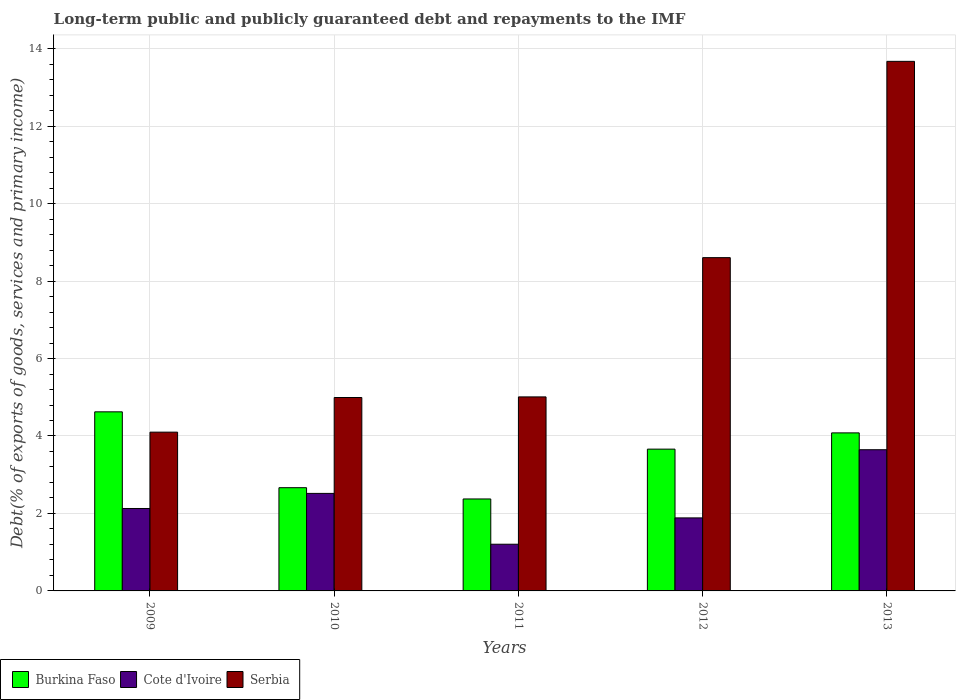How many groups of bars are there?
Ensure brevity in your answer.  5. Are the number of bars per tick equal to the number of legend labels?
Offer a terse response. Yes. Are the number of bars on each tick of the X-axis equal?
Provide a succinct answer. Yes. In how many cases, is the number of bars for a given year not equal to the number of legend labels?
Offer a very short reply. 0. What is the debt and repayments in Serbia in 2010?
Provide a succinct answer. 4.99. Across all years, what is the maximum debt and repayments in Serbia?
Your response must be concise. 13.67. Across all years, what is the minimum debt and repayments in Burkina Faso?
Your response must be concise. 2.37. In which year was the debt and repayments in Burkina Faso minimum?
Offer a terse response. 2011. What is the total debt and repayments in Cote d'Ivoire in the graph?
Your answer should be very brief. 11.38. What is the difference between the debt and repayments in Burkina Faso in 2009 and that in 2011?
Provide a short and direct response. 2.25. What is the difference between the debt and repayments in Burkina Faso in 2009 and the debt and repayments in Cote d'Ivoire in 2013?
Ensure brevity in your answer.  0.98. What is the average debt and repayments in Cote d'Ivoire per year?
Offer a terse response. 2.28. In the year 2010, what is the difference between the debt and repayments in Burkina Faso and debt and repayments in Serbia?
Offer a very short reply. -2.33. In how many years, is the debt and repayments in Serbia greater than 3.2 %?
Keep it short and to the point. 5. What is the ratio of the debt and repayments in Cote d'Ivoire in 2009 to that in 2011?
Your response must be concise. 1.77. Is the debt and repayments in Cote d'Ivoire in 2010 less than that in 2011?
Your answer should be very brief. No. Is the difference between the debt and repayments in Burkina Faso in 2009 and 2011 greater than the difference between the debt and repayments in Serbia in 2009 and 2011?
Offer a terse response. Yes. What is the difference between the highest and the second highest debt and repayments in Burkina Faso?
Offer a very short reply. 0.54. What is the difference between the highest and the lowest debt and repayments in Burkina Faso?
Your answer should be very brief. 2.25. What does the 2nd bar from the left in 2009 represents?
Keep it short and to the point. Cote d'Ivoire. What does the 1st bar from the right in 2009 represents?
Your answer should be compact. Serbia. Are all the bars in the graph horizontal?
Your response must be concise. No. How many years are there in the graph?
Offer a very short reply. 5. Does the graph contain grids?
Ensure brevity in your answer.  Yes. How many legend labels are there?
Offer a terse response. 3. How are the legend labels stacked?
Ensure brevity in your answer.  Horizontal. What is the title of the graph?
Provide a succinct answer. Long-term public and publicly guaranteed debt and repayments to the IMF. Does "Pakistan" appear as one of the legend labels in the graph?
Make the answer very short. No. What is the label or title of the X-axis?
Provide a short and direct response. Years. What is the label or title of the Y-axis?
Your answer should be compact. Debt(% of exports of goods, services and primary income). What is the Debt(% of exports of goods, services and primary income) of Burkina Faso in 2009?
Ensure brevity in your answer.  4.62. What is the Debt(% of exports of goods, services and primary income) in Cote d'Ivoire in 2009?
Provide a short and direct response. 2.13. What is the Debt(% of exports of goods, services and primary income) in Serbia in 2009?
Your response must be concise. 4.1. What is the Debt(% of exports of goods, services and primary income) of Burkina Faso in 2010?
Your answer should be compact. 2.67. What is the Debt(% of exports of goods, services and primary income) in Cote d'Ivoire in 2010?
Provide a short and direct response. 2.52. What is the Debt(% of exports of goods, services and primary income) of Serbia in 2010?
Give a very brief answer. 4.99. What is the Debt(% of exports of goods, services and primary income) in Burkina Faso in 2011?
Your answer should be very brief. 2.37. What is the Debt(% of exports of goods, services and primary income) of Cote d'Ivoire in 2011?
Provide a succinct answer. 1.21. What is the Debt(% of exports of goods, services and primary income) in Serbia in 2011?
Your answer should be very brief. 5.01. What is the Debt(% of exports of goods, services and primary income) in Burkina Faso in 2012?
Provide a succinct answer. 3.66. What is the Debt(% of exports of goods, services and primary income) in Cote d'Ivoire in 2012?
Your answer should be compact. 1.89. What is the Debt(% of exports of goods, services and primary income) in Serbia in 2012?
Your answer should be compact. 8.6. What is the Debt(% of exports of goods, services and primary income) in Burkina Faso in 2013?
Ensure brevity in your answer.  4.08. What is the Debt(% of exports of goods, services and primary income) in Cote d'Ivoire in 2013?
Give a very brief answer. 3.65. What is the Debt(% of exports of goods, services and primary income) of Serbia in 2013?
Give a very brief answer. 13.67. Across all years, what is the maximum Debt(% of exports of goods, services and primary income) of Burkina Faso?
Offer a very short reply. 4.62. Across all years, what is the maximum Debt(% of exports of goods, services and primary income) of Cote d'Ivoire?
Offer a very short reply. 3.65. Across all years, what is the maximum Debt(% of exports of goods, services and primary income) in Serbia?
Your answer should be very brief. 13.67. Across all years, what is the minimum Debt(% of exports of goods, services and primary income) in Burkina Faso?
Give a very brief answer. 2.37. Across all years, what is the minimum Debt(% of exports of goods, services and primary income) in Cote d'Ivoire?
Keep it short and to the point. 1.21. Across all years, what is the minimum Debt(% of exports of goods, services and primary income) in Serbia?
Provide a short and direct response. 4.1. What is the total Debt(% of exports of goods, services and primary income) in Burkina Faso in the graph?
Ensure brevity in your answer.  17.4. What is the total Debt(% of exports of goods, services and primary income) in Cote d'Ivoire in the graph?
Offer a terse response. 11.38. What is the total Debt(% of exports of goods, services and primary income) in Serbia in the graph?
Your answer should be very brief. 36.38. What is the difference between the Debt(% of exports of goods, services and primary income) of Burkina Faso in 2009 and that in 2010?
Offer a very short reply. 1.96. What is the difference between the Debt(% of exports of goods, services and primary income) in Cote d'Ivoire in 2009 and that in 2010?
Ensure brevity in your answer.  -0.39. What is the difference between the Debt(% of exports of goods, services and primary income) in Serbia in 2009 and that in 2010?
Give a very brief answer. -0.89. What is the difference between the Debt(% of exports of goods, services and primary income) of Burkina Faso in 2009 and that in 2011?
Provide a short and direct response. 2.25. What is the difference between the Debt(% of exports of goods, services and primary income) in Cote d'Ivoire in 2009 and that in 2011?
Your answer should be compact. 0.92. What is the difference between the Debt(% of exports of goods, services and primary income) of Serbia in 2009 and that in 2011?
Give a very brief answer. -0.91. What is the difference between the Debt(% of exports of goods, services and primary income) in Burkina Faso in 2009 and that in 2012?
Provide a short and direct response. 0.96. What is the difference between the Debt(% of exports of goods, services and primary income) of Cote d'Ivoire in 2009 and that in 2012?
Your response must be concise. 0.24. What is the difference between the Debt(% of exports of goods, services and primary income) of Serbia in 2009 and that in 2012?
Your response must be concise. -4.51. What is the difference between the Debt(% of exports of goods, services and primary income) in Burkina Faso in 2009 and that in 2013?
Your answer should be very brief. 0.54. What is the difference between the Debt(% of exports of goods, services and primary income) of Cote d'Ivoire in 2009 and that in 2013?
Offer a terse response. -1.52. What is the difference between the Debt(% of exports of goods, services and primary income) of Serbia in 2009 and that in 2013?
Offer a very short reply. -9.57. What is the difference between the Debt(% of exports of goods, services and primary income) of Burkina Faso in 2010 and that in 2011?
Offer a very short reply. 0.29. What is the difference between the Debt(% of exports of goods, services and primary income) in Cote d'Ivoire in 2010 and that in 2011?
Your answer should be compact. 1.31. What is the difference between the Debt(% of exports of goods, services and primary income) in Serbia in 2010 and that in 2011?
Offer a very short reply. -0.02. What is the difference between the Debt(% of exports of goods, services and primary income) of Burkina Faso in 2010 and that in 2012?
Offer a very short reply. -1. What is the difference between the Debt(% of exports of goods, services and primary income) in Cote d'Ivoire in 2010 and that in 2012?
Make the answer very short. 0.63. What is the difference between the Debt(% of exports of goods, services and primary income) of Serbia in 2010 and that in 2012?
Offer a terse response. -3.61. What is the difference between the Debt(% of exports of goods, services and primary income) of Burkina Faso in 2010 and that in 2013?
Your response must be concise. -1.42. What is the difference between the Debt(% of exports of goods, services and primary income) in Cote d'Ivoire in 2010 and that in 2013?
Your response must be concise. -1.13. What is the difference between the Debt(% of exports of goods, services and primary income) of Serbia in 2010 and that in 2013?
Keep it short and to the point. -8.68. What is the difference between the Debt(% of exports of goods, services and primary income) of Burkina Faso in 2011 and that in 2012?
Keep it short and to the point. -1.29. What is the difference between the Debt(% of exports of goods, services and primary income) in Cote d'Ivoire in 2011 and that in 2012?
Provide a succinct answer. -0.68. What is the difference between the Debt(% of exports of goods, services and primary income) in Serbia in 2011 and that in 2012?
Your answer should be very brief. -3.6. What is the difference between the Debt(% of exports of goods, services and primary income) in Burkina Faso in 2011 and that in 2013?
Make the answer very short. -1.71. What is the difference between the Debt(% of exports of goods, services and primary income) in Cote d'Ivoire in 2011 and that in 2013?
Provide a short and direct response. -2.44. What is the difference between the Debt(% of exports of goods, services and primary income) in Serbia in 2011 and that in 2013?
Make the answer very short. -8.66. What is the difference between the Debt(% of exports of goods, services and primary income) in Burkina Faso in 2012 and that in 2013?
Give a very brief answer. -0.42. What is the difference between the Debt(% of exports of goods, services and primary income) of Cote d'Ivoire in 2012 and that in 2013?
Make the answer very short. -1.76. What is the difference between the Debt(% of exports of goods, services and primary income) in Serbia in 2012 and that in 2013?
Offer a very short reply. -5.07. What is the difference between the Debt(% of exports of goods, services and primary income) in Burkina Faso in 2009 and the Debt(% of exports of goods, services and primary income) in Cote d'Ivoire in 2010?
Provide a short and direct response. 2.11. What is the difference between the Debt(% of exports of goods, services and primary income) in Burkina Faso in 2009 and the Debt(% of exports of goods, services and primary income) in Serbia in 2010?
Provide a succinct answer. -0.37. What is the difference between the Debt(% of exports of goods, services and primary income) of Cote d'Ivoire in 2009 and the Debt(% of exports of goods, services and primary income) of Serbia in 2010?
Ensure brevity in your answer.  -2.87. What is the difference between the Debt(% of exports of goods, services and primary income) of Burkina Faso in 2009 and the Debt(% of exports of goods, services and primary income) of Cote d'Ivoire in 2011?
Ensure brevity in your answer.  3.42. What is the difference between the Debt(% of exports of goods, services and primary income) of Burkina Faso in 2009 and the Debt(% of exports of goods, services and primary income) of Serbia in 2011?
Provide a succinct answer. -0.39. What is the difference between the Debt(% of exports of goods, services and primary income) of Cote d'Ivoire in 2009 and the Debt(% of exports of goods, services and primary income) of Serbia in 2011?
Your response must be concise. -2.88. What is the difference between the Debt(% of exports of goods, services and primary income) of Burkina Faso in 2009 and the Debt(% of exports of goods, services and primary income) of Cote d'Ivoire in 2012?
Give a very brief answer. 2.74. What is the difference between the Debt(% of exports of goods, services and primary income) of Burkina Faso in 2009 and the Debt(% of exports of goods, services and primary income) of Serbia in 2012?
Provide a succinct answer. -3.98. What is the difference between the Debt(% of exports of goods, services and primary income) in Cote d'Ivoire in 2009 and the Debt(% of exports of goods, services and primary income) in Serbia in 2012?
Your answer should be very brief. -6.48. What is the difference between the Debt(% of exports of goods, services and primary income) in Burkina Faso in 2009 and the Debt(% of exports of goods, services and primary income) in Cote d'Ivoire in 2013?
Ensure brevity in your answer.  0.98. What is the difference between the Debt(% of exports of goods, services and primary income) of Burkina Faso in 2009 and the Debt(% of exports of goods, services and primary income) of Serbia in 2013?
Give a very brief answer. -9.05. What is the difference between the Debt(% of exports of goods, services and primary income) of Cote d'Ivoire in 2009 and the Debt(% of exports of goods, services and primary income) of Serbia in 2013?
Ensure brevity in your answer.  -11.54. What is the difference between the Debt(% of exports of goods, services and primary income) in Burkina Faso in 2010 and the Debt(% of exports of goods, services and primary income) in Cote d'Ivoire in 2011?
Offer a terse response. 1.46. What is the difference between the Debt(% of exports of goods, services and primary income) in Burkina Faso in 2010 and the Debt(% of exports of goods, services and primary income) in Serbia in 2011?
Your answer should be compact. -2.34. What is the difference between the Debt(% of exports of goods, services and primary income) in Cote d'Ivoire in 2010 and the Debt(% of exports of goods, services and primary income) in Serbia in 2011?
Give a very brief answer. -2.49. What is the difference between the Debt(% of exports of goods, services and primary income) of Burkina Faso in 2010 and the Debt(% of exports of goods, services and primary income) of Cote d'Ivoire in 2012?
Offer a very short reply. 0.78. What is the difference between the Debt(% of exports of goods, services and primary income) in Burkina Faso in 2010 and the Debt(% of exports of goods, services and primary income) in Serbia in 2012?
Make the answer very short. -5.94. What is the difference between the Debt(% of exports of goods, services and primary income) in Cote d'Ivoire in 2010 and the Debt(% of exports of goods, services and primary income) in Serbia in 2012?
Your response must be concise. -6.09. What is the difference between the Debt(% of exports of goods, services and primary income) in Burkina Faso in 2010 and the Debt(% of exports of goods, services and primary income) in Cote d'Ivoire in 2013?
Your response must be concise. -0.98. What is the difference between the Debt(% of exports of goods, services and primary income) of Burkina Faso in 2010 and the Debt(% of exports of goods, services and primary income) of Serbia in 2013?
Your response must be concise. -11.01. What is the difference between the Debt(% of exports of goods, services and primary income) in Cote d'Ivoire in 2010 and the Debt(% of exports of goods, services and primary income) in Serbia in 2013?
Your answer should be compact. -11.15. What is the difference between the Debt(% of exports of goods, services and primary income) of Burkina Faso in 2011 and the Debt(% of exports of goods, services and primary income) of Cote d'Ivoire in 2012?
Offer a terse response. 0.49. What is the difference between the Debt(% of exports of goods, services and primary income) in Burkina Faso in 2011 and the Debt(% of exports of goods, services and primary income) in Serbia in 2012?
Offer a terse response. -6.23. What is the difference between the Debt(% of exports of goods, services and primary income) of Cote d'Ivoire in 2011 and the Debt(% of exports of goods, services and primary income) of Serbia in 2012?
Your response must be concise. -7.4. What is the difference between the Debt(% of exports of goods, services and primary income) in Burkina Faso in 2011 and the Debt(% of exports of goods, services and primary income) in Cote d'Ivoire in 2013?
Your answer should be compact. -1.27. What is the difference between the Debt(% of exports of goods, services and primary income) of Burkina Faso in 2011 and the Debt(% of exports of goods, services and primary income) of Serbia in 2013?
Keep it short and to the point. -11.3. What is the difference between the Debt(% of exports of goods, services and primary income) in Cote d'Ivoire in 2011 and the Debt(% of exports of goods, services and primary income) in Serbia in 2013?
Make the answer very short. -12.47. What is the difference between the Debt(% of exports of goods, services and primary income) of Burkina Faso in 2012 and the Debt(% of exports of goods, services and primary income) of Cote d'Ivoire in 2013?
Your response must be concise. 0.02. What is the difference between the Debt(% of exports of goods, services and primary income) of Burkina Faso in 2012 and the Debt(% of exports of goods, services and primary income) of Serbia in 2013?
Offer a very short reply. -10.01. What is the difference between the Debt(% of exports of goods, services and primary income) in Cote d'Ivoire in 2012 and the Debt(% of exports of goods, services and primary income) in Serbia in 2013?
Make the answer very short. -11.79. What is the average Debt(% of exports of goods, services and primary income) of Burkina Faso per year?
Offer a terse response. 3.48. What is the average Debt(% of exports of goods, services and primary income) in Cote d'Ivoire per year?
Provide a succinct answer. 2.28. What is the average Debt(% of exports of goods, services and primary income) of Serbia per year?
Your response must be concise. 7.28. In the year 2009, what is the difference between the Debt(% of exports of goods, services and primary income) in Burkina Faso and Debt(% of exports of goods, services and primary income) in Cote d'Ivoire?
Provide a short and direct response. 2.5. In the year 2009, what is the difference between the Debt(% of exports of goods, services and primary income) of Burkina Faso and Debt(% of exports of goods, services and primary income) of Serbia?
Make the answer very short. 0.52. In the year 2009, what is the difference between the Debt(% of exports of goods, services and primary income) in Cote d'Ivoire and Debt(% of exports of goods, services and primary income) in Serbia?
Provide a succinct answer. -1.97. In the year 2010, what is the difference between the Debt(% of exports of goods, services and primary income) of Burkina Faso and Debt(% of exports of goods, services and primary income) of Cote d'Ivoire?
Make the answer very short. 0.15. In the year 2010, what is the difference between the Debt(% of exports of goods, services and primary income) of Burkina Faso and Debt(% of exports of goods, services and primary income) of Serbia?
Provide a short and direct response. -2.33. In the year 2010, what is the difference between the Debt(% of exports of goods, services and primary income) in Cote d'Ivoire and Debt(% of exports of goods, services and primary income) in Serbia?
Offer a terse response. -2.48. In the year 2011, what is the difference between the Debt(% of exports of goods, services and primary income) of Burkina Faso and Debt(% of exports of goods, services and primary income) of Cote d'Ivoire?
Provide a short and direct response. 1.17. In the year 2011, what is the difference between the Debt(% of exports of goods, services and primary income) in Burkina Faso and Debt(% of exports of goods, services and primary income) in Serbia?
Your response must be concise. -2.64. In the year 2011, what is the difference between the Debt(% of exports of goods, services and primary income) in Cote d'Ivoire and Debt(% of exports of goods, services and primary income) in Serbia?
Your answer should be compact. -3.8. In the year 2012, what is the difference between the Debt(% of exports of goods, services and primary income) in Burkina Faso and Debt(% of exports of goods, services and primary income) in Cote d'Ivoire?
Provide a succinct answer. 1.78. In the year 2012, what is the difference between the Debt(% of exports of goods, services and primary income) in Burkina Faso and Debt(% of exports of goods, services and primary income) in Serbia?
Keep it short and to the point. -4.94. In the year 2012, what is the difference between the Debt(% of exports of goods, services and primary income) of Cote d'Ivoire and Debt(% of exports of goods, services and primary income) of Serbia?
Give a very brief answer. -6.72. In the year 2013, what is the difference between the Debt(% of exports of goods, services and primary income) of Burkina Faso and Debt(% of exports of goods, services and primary income) of Cote d'Ivoire?
Offer a terse response. 0.43. In the year 2013, what is the difference between the Debt(% of exports of goods, services and primary income) in Burkina Faso and Debt(% of exports of goods, services and primary income) in Serbia?
Provide a succinct answer. -9.59. In the year 2013, what is the difference between the Debt(% of exports of goods, services and primary income) in Cote d'Ivoire and Debt(% of exports of goods, services and primary income) in Serbia?
Your answer should be very brief. -10.03. What is the ratio of the Debt(% of exports of goods, services and primary income) of Burkina Faso in 2009 to that in 2010?
Keep it short and to the point. 1.73. What is the ratio of the Debt(% of exports of goods, services and primary income) in Cote d'Ivoire in 2009 to that in 2010?
Keep it short and to the point. 0.85. What is the ratio of the Debt(% of exports of goods, services and primary income) of Serbia in 2009 to that in 2010?
Offer a terse response. 0.82. What is the ratio of the Debt(% of exports of goods, services and primary income) in Burkina Faso in 2009 to that in 2011?
Ensure brevity in your answer.  1.95. What is the ratio of the Debt(% of exports of goods, services and primary income) in Cote d'Ivoire in 2009 to that in 2011?
Your answer should be compact. 1.77. What is the ratio of the Debt(% of exports of goods, services and primary income) of Serbia in 2009 to that in 2011?
Provide a succinct answer. 0.82. What is the ratio of the Debt(% of exports of goods, services and primary income) of Burkina Faso in 2009 to that in 2012?
Provide a succinct answer. 1.26. What is the ratio of the Debt(% of exports of goods, services and primary income) in Cote d'Ivoire in 2009 to that in 2012?
Make the answer very short. 1.13. What is the ratio of the Debt(% of exports of goods, services and primary income) in Serbia in 2009 to that in 2012?
Offer a terse response. 0.48. What is the ratio of the Debt(% of exports of goods, services and primary income) in Burkina Faso in 2009 to that in 2013?
Your answer should be very brief. 1.13. What is the ratio of the Debt(% of exports of goods, services and primary income) in Cote d'Ivoire in 2009 to that in 2013?
Offer a very short reply. 0.58. What is the ratio of the Debt(% of exports of goods, services and primary income) of Serbia in 2009 to that in 2013?
Give a very brief answer. 0.3. What is the ratio of the Debt(% of exports of goods, services and primary income) in Burkina Faso in 2010 to that in 2011?
Keep it short and to the point. 1.12. What is the ratio of the Debt(% of exports of goods, services and primary income) of Cote d'Ivoire in 2010 to that in 2011?
Your answer should be compact. 2.09. What is the ratio of the Debt(% of exports of goods, services and primary income) in Serbia in 2010 to that in 2011?
Provide a short and direct response. 1. What is the ratio of the Debt(% of exports of goods, services and primary income) of Burkina Faso in 2010 to that in 2012?
Your response must be concise. 0.73. What is the ratio of the Debt(% of exports of goods, services and primary income) in Cote d'Ivoire in 2010 to that in 2012?
Your answer should be compact. 1.34. What is the ratio of the Debt(% of exports of goods, services and primary income) in Serbia in 2010 to that in 2012?
Provide a short and direct response. 0.58. What is the ratio of the Debt(% of exports of goods, services and primary income) in Burkina Faso in 2010 to that in 2013?
Ensure brevity in your answer.  0.65. What is the ratio of the Debt(% of exports of goods, services and primary income) of Cote d'Ivoire in 2010 to that in 2013?
Make the answer very short. 0.69. What is the ratio of the Debt(% of exports of goods, services and primary income) of Serbia in 2010 to that in 2013?
Provide a succinct answer. 0.37. What is the ratio of the Debt(% of exports of goods, services and primary income) of Burkina Faso in 2011 to that in 2012?
Give a very brief answer. 0.65. What is the ratio of the Debt(% of exports of goods, services and primary income) of Cote d'Ivoire in 2011 to that in 2012?
Your answer should be very brief. 0.64. What is the ratio of the Debt(% of exports of goods, services and primary income) of Serbia in 2011 to that in 2012?
Make the answer very short. 0.58. What is the ratio of the Debt(% of exports of goods, services and primary income) in Burkina Faso in 2011 to that in 2013?
Give a very brief answer. 0.58. What is the ratio of the Debt(% of exports of goods, services and primary income) in Cote d'Ivoire in 2011 to that in 2013?
Give a very brief answer. 0.33. What is the ratio of the Debt(% of exports of goods, services and primary income) of Serbia in 2011 to that in 2013?
Your answer should be very brief. 0.37. What is the ratio of the Debt(% of exports of goods, services and primary income) of Burkina Faso in 2012 to that in 2013?
Keep it short and to the point. 0.9. What is the ratio of the Debt(% of exports of goods, services and primary income) of Cote d'Ivoire in 2012 to that in 2013?
Make the answer very short. 0.52. What is the ratio of the Debt(% of exports of goods, services and primary income) of Serbia in 2012 to that in 2013?
Your response must be concise. 0.63. What is the difference between the highest and the second highest Debt(% of exports of goods, services and primary income) in Burkina Faso?
Give a very brief answer. 0.54. What is the difference between the highest and the second highest Debt(% of exports of goods, services and primary income) in Cote d'Ivoire?
Your answer should be compact. 1.13. What is the difference between the highest and the second highest Debt(% of exports of goods, services and primary income) of Serbia?
Offer a terse response. 5.07. What is the difference between the highest and the lowest Debt(% of exports of goods, services and primary income) in Burkina Faso?
Your answer should be very brief. 2.25. What is the difference between the highest and the lowest Debt(% of exports of goods, services and primary income) of Cote d'Ivoire?
Offer a terse response. 2.44. What is the difference between the highest and the lowest Debt(% of exports of goods, services and primary income) in Serbia?
Ensure brevity in your answer.  9.57. 